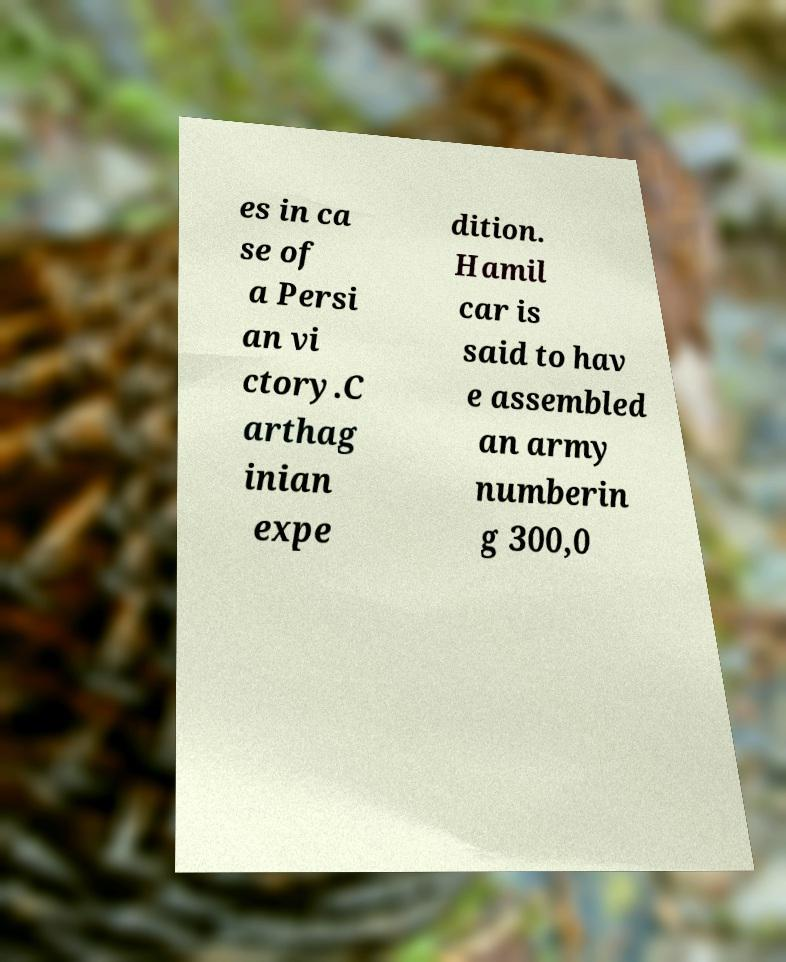There's text embedded in this image that I need extracted. Can you transcribe it verbatim? es in ca se of a Persi an vi ctory.C arthag inian expe dition. Hamil car is said to hav e assembled an army numberin g 300,0 